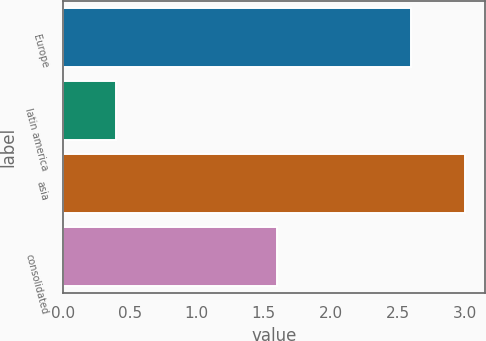<chart> <loc_0><loc_0><loc_500><loc_500><bar_chart><fcel>Europe<fcel>latin america<fcel>asia<fcel>consolidated<nl><fcel>2.6<fcel>0.4<fcel>3<fcel>1.6<nl></chart> 